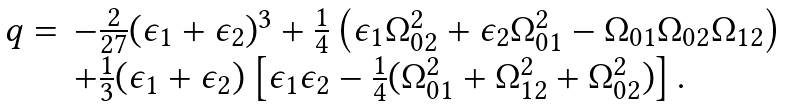<formula> <loc_0><loc_0><loc_500><loc_500>\begin{array} { l l } q = & - \frac { 2 } { 2 7 } ( \epsilon _ { 1 } + \epsilon _ { 2 } ) ^ { 3 } + \frac { 1 } { 4 } \left ( \epsilon _ { 1 } \Omega _ { 0 2 } ^ { 2 } + \epsilon _ { 2 } \Omega _ { 0 1 } ^ { 2 } - \Omega _ { 0 1 } \Omega _ { 0 2 } \Omega _ { 1 2 } \right ) \\ & + \frac { 1 } { 3 } ( \epsilon _ { 1 } + \epsilon _ { 2 } ) \left [ \epsilon _ { 1 } \epsilon _ { 2 } - \frac { 1 } { 4 } ( \Omega _ { 0 1 } ^ { 2 } + \Omega _ { 1 2 } ^ { 2 } + \Omega _ { 0 2 } ^ { 2 } ) \right ] . \end{array}</formula> 